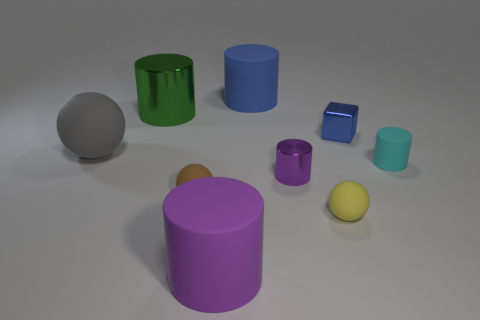How many objects are either tiny brown metallic spheres or metal cylinders behind the purple shiny object?
Ensure brevity in your answer.  1. Are there the same number of blue objects that are on the left side of the blue cylinder and tiny green shiny cylinders?
Keep it short and to the point. Yes. What shape is the brown object that is made of the same material as the small yellow thing?
Offer a terse response. Sphere. Are there any objects that have the same color as the metal cube?
Provide a succinct answer. Yes. What number of rubber things are big purple things or small brown objects?
Ensure brevity in your answer.  2. There is a cyan matte cylinder behind the brown object; how many tiny purple objects are behind it?
Keep it short and to the point. 0. What number of tiny blue blocks have the same material as the small cyan cylinder?
Provide a succinct answer. 0. What number of tiny things are either purple cylinders or yellow rubber spheres?
Make the answer very short. 2. The thing that is both to the left of the blue cylinder and behind the large gray thing has what shape?
Keep it short and to the point. Cylinder. Do the big purple cylinder and the big blue cylinder have the same material?
Your response must be concise. Yes. 